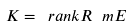Convert formula to latex. <formula><loc_0><loc_0><loc_500><loc_500>K = \ r a n k R _ { \ } m E</formula> 